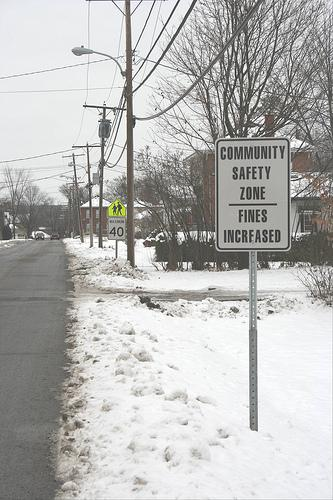Question: who is in this picture?
Choices:
A. Two dogs.
B. An airplane.
C. There are no people.
D. A car.
Answer with the letter. Answer: C Question: why is there a sign?
Choices:
A. To keep people out.
B. To keep people safe.
C. To keep people quiet.
D. To keep people in line.
Answer with the letter. Answer: B Question: where is the snow?
Choices:
A. On the car.
B. On the roof.
C. On the ground.
D. On the trees.
Answer with the letter. Answer: C 